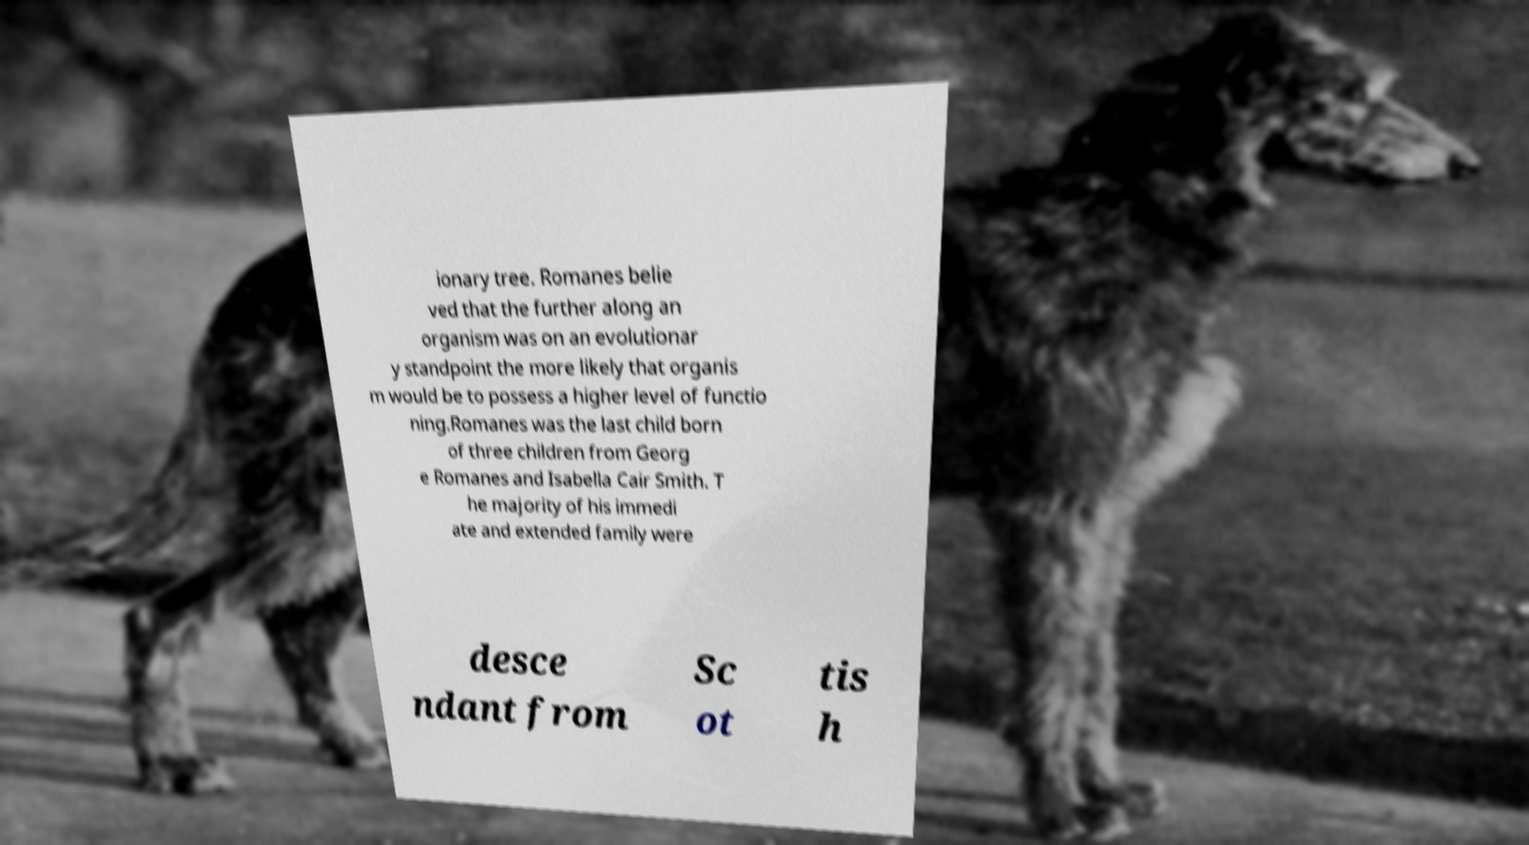Can you accurately transcribe the text from the provided image for me? ionary tree. Romanes belie ved that the further along an organism was on an evolutionar y standpoint the more likely that organis m would be to possess a higher level of functio ning.Romanes was the last child born of three children from Georg e Romanes and Isabella Cair Smith. T he majority of his immedi ate and extended family were desce ndant from Sc ot tis h 